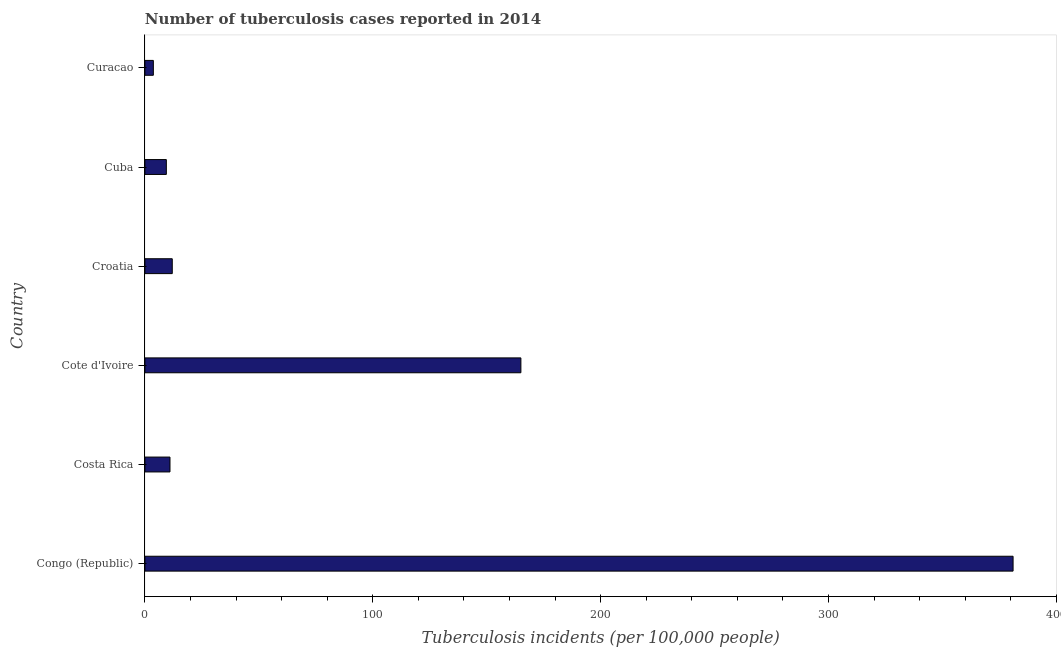Does the graph contain any zero values?
Your answer should be compact. No. What is the title of the graph?
Provide a short and direct response. Number of tuberculosis cases reported in 2014. What is the label or title of the X-axis?
Ensure brevity in your answer.  Tuberculosis incidents (per 100,0 people). What is the label or title of the Y-axis?
Your response must be concise. Country. What is the number of tuberculosis incidents in Croatia?
Offer a terse response. 12. Across all countries, what is the maximum number of tuberculosis incidents?
Provide a succinct answer. 381. In which country was the number of tuberculosis incidents maximum?
Make the answer very short. Congo (Republic). In which country was the number of tuberculosis incidents minimum?
Give a very brief answer. Curacao. What is the sum of the number of tuberculosis incidents?
Offer a terse response. 582.1. What is the average number of tuberculosis incidents per country?
Ensure brevity in your answer.  97.02. What is the ratio of the number of tuberculosis incidents in Croatia to that in Curacao?
Your response must be concise. 3.24. What is the difference between the highest and the second highest number of tuberculosis incidents?
Make the answer very short. 216. Is the sum of the number of tuberculosis incidents in Croatia and Curacao greater than the maximum number of tuberculosis incidents across all countries?
Give a very brief answer. No. What is the difference between the highest and the lowest number of tuberculosis incidents?
Your answer should be very brief. 377.3. How many bars are there?
Your answer should be compact. 6. Are the values on the major ticks of X-axis written in scientific E-notation?
Offer a very short reply. No. What is the Tuberculosis incidents (per 100,000 people) of Congo (Republic)?
Your answer should be very brief. 381. What is the Tuberculosis incidents (per 100,000 people) of Cote d'Ivoire?
Keep it short and to the point. 165. What is the Tuberculosis incidents (per 100,000 people) in Croatia?
Your answer should be very brief. 12. What is the difference between the Tuberculosis incidents (per 100,000 people) in Congo (Republic) and Costa Rica?
Provide a succinct answer. 370. What is the difference between the Tuberculosis incidents (per 100,000 people) in Congo (Republic) and Cote d'Ivoire?
Your answer should be very brief. 216. What is the difference between the Tuberculosis incidents (per 100,000 people) in Congo (Republic) and Croatia?
Offer a very short reply. 369. What is the difference between the Tuberculosis incidents (per 100,000 people) in Congo (Republic) and Cuba?
Provide a succinct answer. 371.6. What is the difference between the Tuberculosis incidents (per 100,000 people) in Congo (Republic) and Curacao?
Ensure brevity in your answer.  377.3. What is the difference between the Tuberculosis incidents (per 100,000 people) in Costa Rica and Cote d'Ivoire?
Provide a short and direct response. -154. What is the difference between the Tuberculosis incidents (per 100,000 people) in Costa Rica and Croatia?
Keep it short and to the point. -1. What is the difference between the Tuberculosis incidents (per 100,000 people) in Costa Rica and Curacao?
Your response must be concise. 7.3. What is the difference between the Tuberculosis incidents (per 100,000 people) in Cote d'Ivoire and Croatia?
Your answer should be compact. 153. What is the difference between the Tuberculosis incidents (per 100,000 people) in Cote d'Ivoire and Cuba?
Offer a terse response. 155.6. What is the difference between the Tuberculosis incidents (per 100,000 people) in Cote d'Ivoire and Curacao?
Provide a succinct answer. 161.3. What is the difference between the Tuberculosis incidents (per 100,000 people) in Croatia and Cuba?
Your answer should be compact. 2.6. What is the difference between the Tuberculosis incidents (per 100,000 people) in Croatia and Curacao?
Your answer should be very brief. 8.3. What is the ratio of the Tuberculosis incidents (per 100,000 people) in Congo (Republic) to that in Costa Rica?
Offer a terse response. 34.64. What is the ratio of the Tuberculosis incidents (per 100,000 people) in Congo (Republic) to that in Cote d'Ivoire?
Make the answer very short. 2.31. What is the ratio of the Tuberculosis incidents (per 100,000 people) in Congo (Republic) to that in Croatia?
Give a very brief answer. 31.75. What is the ratio of the Tuberculosis incidents (per 100,000 people) in Congo (Republic) to that in Cuba?
Your response must be concise. 40.53. What is the ratio of the Tuberculosis incidents (per 100,000 people) in Congo (Republic) to that in Curacao?
Offer a very short reply. 102.97. What is the ratio of the Tuberculosis incidents (per 100,000 people) in Costa Rica to that in Cote d'Ivoire?
Provide a short and direct response. 0.07. What is the ratio of the Tuberculosis incidents (per 100,000 people) in Costa Rica to that in Croatia?
Your answer should be compact. 0.92. What is the ratio of the Tuberculosis incidents (per 100,000 people) in Costa Rica to that in Cuba?
Provide a succinct answer. 1.17. What is the ratio of the Tuberculosis incidents (per 100,000 people) in Costa Rica to that in Curacao?
Your response must be concise. 2.97. What is the ratio of the Tuberculosis incidents (per 100,000 people) in Cote d'Ivoire to that in Croatia?
Your response must be concise. 13.75. What is the ratio of the Tuberculosis incidents (per 100,000 people) in Cote d'Ivoire to that in Cuba?
Make the answer very short. 17.55. What is the ratio of the Tuberculosis incidents (per 100,000 people) in Cote d'Ivoire to that in Curacao?
Make the answer very short. 44.59. What is the ratio of the Tuberculosis incidents (per 100,000 people) in Croatia to that in Cuba?
Offer a terse response. 1.28. What is the ratio of the Tuberculosis incidents (per 100,000 people) in Croatia to that in Curacao?
Provide a succinct answer. 3.24. What is the ratio of the Tuberculosis incidents (per 100,000 people) in Cuba to that in Curacao?
Make the answer very short. 2.54. 